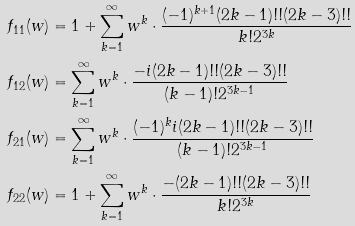Convert formula to latex. <formula><loc_0><loc_0><loc_500><loc_500>f _ { 1 1 } ( w ) & = 1 + \sum _ { k = 1 } ^ { \infty } w ^ { k } \cdot \frac { ( - 1 ) ^ { k + 1 } ( 2 k - 1 ) ! ! ( 2 k - 3 ) ! ! } { k ! 2 ^ { 3 k } } \\ f _ { 1 2 } ( w ) & = \sum _ { k = 1 } ^ { \infty } w ^ { k } \cdot \frac { - i ( 2 k - 1 ) ! ! ( 2 k - 3 ) ! ! } { ( k - 1 ) ! 2 ^ { 3 k - 1 } } \\ f _ { 2 1 } ( w ) & = \sum _ { k = 1 } ^ { \infty } w ^ { k } \cdot \frac { ( - 1 ) ^ { k } i ( 2 k - 1 ) ! ! ( 2 k - 3 ) ! ! } { ( k - 1 ) ! 2 ^ { 3 k - 1 } } \\ f _ { 2 2 } ( w ) & = 1 + \sum _ { k = 1 } ^ { \infty } w ^ { k } \cdot \frac { - ( 2 k - 1 ) ! ! ( 2 k - 3 ) ! ! } { k ! 2 ^ { 3 k } }</formula> 